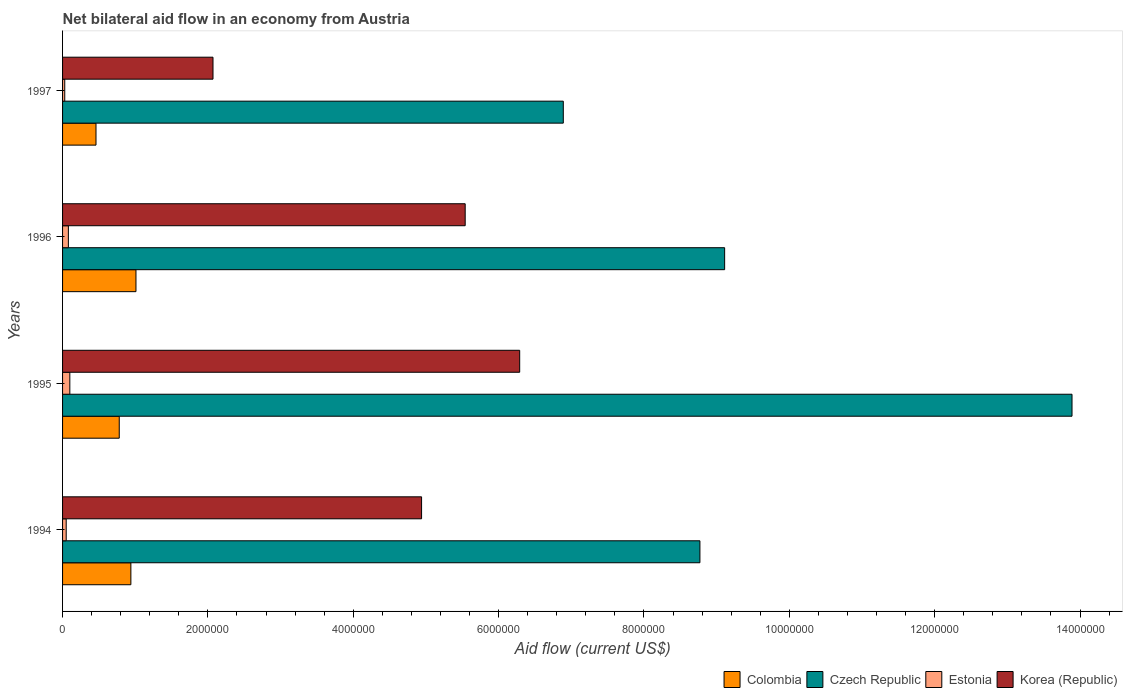How many different coloured bars are there?
Your answer should be compact. 4. Are the number of bars per tick equal to the number of legend labels?
Give a very brief answer. Yes. How many bars are there on the 2nd tick from the top?
Make the answer very short. 4. How many bars are there on the 2nd tick from the bottom?
Provide a succinct answer. 4. In how many cases, is the number of bars for a given year not equal to the number of legend labels?
Give a very brief answer. 0. What is the net bilateral aid flow in Czech Republic in 1994?
Provide a succinct answer. 8.77e+06. Across all years, what is the maximum net bilateral aid flow in Colombia?
Provide a succinct answer. 1.01e+06. Across all years, what is the minimum net bilateral aid flow in Colombia?
Give a very brief answer. 4.60e+05. What is the total net bilateral aid flow in Korea (Republic) in the graph?
Make the answer very short. 1.88e+07. What is the difference between the net bilateral aid flow in Colombia in 1995 and that in 1996?
Provide a short and direct response. -2.30e+05. What is the difference between the net bilateral aid flow in Estonia in 1995 and the net bilateral aid flow in Colombia in 1997?
Offer a very short reply. -3.60e+05. What is the average net bilateral aid flow in Colombia per year?
Your answer should be compact. 7.98e+05. In the year 1997, what is the difference between the net bilateral aid flow in Czech Republic and net bilateral aid flow in Korea (Republic)?
Provide a succinct answer. 4.82e+06. What is the ratio of the net bilateral aid flow in Korea (Republic) in 1995 to that in 1997?
Offer a terse response. 3.04. Is the difference between the net bilateral aid flow in Czech Republic in 1994 and 1996 greater than the difference between the net bilateral aid flow in Korea (Republic) in 1994 and 1996?
Make the answer very short. Yes. What is the difference between the highest and the lowest net bilateral aid flow in Estonia?
Ensure brevity in your answer.  7.00e+04. In how many years, is the net bilateral aid flow in Estonia greater than the average net bilateral aid flow in Estonia taken over all years?
Your answer should be very brief. 2. Is it the case that in every year, the sum of the net bilateral aid flow in Czech Republic and net bilateral aid flow in Colombia is greater than the sum of net bilateral aid flow in Korea (Republic) and net bilateral aid flow in Estonia?
Give a very brief answer. No. What does the 3rd bar from the top in 1995 represents?
Offer a terse response. Czech Republic. Is it the case that in every year, the sum of the net bilateral aid flow in Estonia and net bilateral aid flow in Czech Republic is greater than the net bilateral aid flow in Colombia?
Your answer should be very brief. Yes. How many bars are there?
Ensure brevity in your answer.  16. How many years are there in the graph?
Give a very brief answer. 4. What is the difference between two consecutive major ticks on the X-axis?
Provide a succinct answer. 2.00e+06. Are the values on the major ticks of X-axis written in scientific E-notation?
Your response must be concise. No. Does the graph contain any zero values?
Offer a terse response. No. Does the graph contain grids?
Keep it short and to the point. No. Where does the legend appear in the graph?
Offer a terse response. Bottom right. How many legend labels are there?
Ensure brevity in your answer.  4. What is the title of the graph?
Provide a succinct answer. Net bilateral aid flow in an economy from Austria. What is the label or title of the Y-axis?
Ensure brevity in your answer.  Years. What is the Aid flow (current US$) in Colombia in 1994?
Offer a very short reply. 9.40e+05. What is the Aid flow (current US$) of Czech Republic in 1994?
Make the answer very short. 8.77e+06. What is the Aid flow (current US$) of Estonia in 1994?
Provide a succinct answer. 5.00e+04. What is the Aid flow (current US$) in Korea (Republic) in 1994?
Provide a succinct answer. 4.94e+06. What is the Aid flow (current US$) in Colombia in 1995?
Your answer should be very brief. 7.80e+05. What is the Aid flow (current US$) in Czech Republic in 1995?
Offer a terse response. 1.39e+07. What is the Aid flow (current US$) in Estonia in 1995?
Give a very brief answer. 1.00e+05. What is the Aid flow (current US$) in Korea (Republic) in 1995?
Your answer should be compact. 6.29e+06. What is the Aid flow (current US$) in Colombia in 1996?
Give a very brief answer. 1.01e+06. What is the Aid flow (current US$) of Czech Republic in 1996?
Give a very brief answer. 9.11e+06. What is the Aid flow (current US$) in Korea (Republic) in 1996?
Your answer should be compact. 5.54e+06. What is the Aid flow (current US$) of Colombia in 1997?
Make the answer very short. 4.60e+05. What is the Aid flow (current US$) of Czech Republic in 1997?
Your answer should be compact. 6.89e+06. What is the Aid flow (current US$) in Estonia in 1997?
Make the answer very short. 3.00e+04. What is the Aid flow (current US$) in Korea (Republic) in 1997?
Keep it short and to the point. 2.07e+06. Across all years, what is the maximum Aid flow (current US$) of Colombia?
Keep it short and to the point. 1.01e+06. Across all years, what is the maximum Aid flow (current US$) of Czech Republic?
Offer a terse response. 1.39e+07. Across all years, what is the maximum Aid flow (current US$) of Korea (Republic)?
Offer a terse response. 6.29e+06. Across all years, what is the minimum Aid flow (current US$) of Czech Republic?
Provide a short and direct response. 6.89e+06. Across all years, what is the minimum Aid flow (current US$) of Korea (Republic)?
Your answer should be compact. 2.07e+06. What is the total Aid flow (current US$) of Colombia in the graph?
Ensure brevity in your answer.  3.19e+06. What is the total Aid flow (current US$) in Czech Republic in the graph?
Provide a short and direct response. 3.87e+07. What is the total Aid flow (current US$) in Korea (Republic) in the graph?
Provide a succinct answer. 1.88e+07. What is the difference between the Aid flow (current US$) of Czech Republic in 1994 and that in 1995?
Provide a succinct answer. -5.12e+06. What is the difference between the Aid flow (current US$) of Estonia in 1994 and that in 1995?
Give a very brief answer. -5.00e+04. What is the difference between the Aid flow (current US$) in Korea (Republic) in 1994 and that in 1995?
Your response must be concise. -1.35e+06. What is the difference between the Aid flow (current US$) in Colombia in 1994 and that in 1996?
Provide a short and direct response. -7.00e+04. What is the difference between the Aid flow (current US$) in Czech Republic in 1994 and that in 1996?
Ensure brevity in your answer.  -3.40e+05. What is the difference between the Aid flow (current US$) in Estonia in 1994 and that in 1996?
Ensure brevity in your answer.  -3.00e+04. What is the difference between the Aid flow (current US$) in Korea (Republic) in 1994 and that in 1996?
Give a very brief answer. -6.00e+05. What is the difference between the Aid flow (current US$) of Colombia in 1994 and that in 1997?
Your answer should be compact. 4.80e+05. What is the difference between the Aid flow (current US$) in Czech Republic in 1994 and that in 1997?
Your answer should be very brief. 1.88e+06. What is the difference between the Aid flow (current US$) in Estonia in 1994 and that in 1997?
Provide a short and direct response. 2.00e+04. What is the difference between the Aid flow (current US$) in Korea (Republic) in 1994 and that in 1997?
Offer a terse response. 2.87e+06. What is the difference between the Aid flow (current US$) of Czech Republic in 1995 and that in 1996?
Ensure brevity in your answer.  4.78e+06. What is the difference between the Aid flow (current US$) of Estonia in 1995 and that in 1996?
Offer a very short reply. 2.00e+04. What is the difference between the Aid flow (current US$) in Korea (Republic) in 1995 and that in 1996?
Provide a succinct answer. 7.50e+05. What is the difference between the Aid flow (current US$) in Colombia in 1995 and that in 1997?
Offer a terse response. 3.20e+05. What is the difference between the Aid flow (current US$) of Estonia in 1995 and that in 1997?
Offer a very short reply. 7.00e+04. What is the difference between the Aid flow (current US$) in Korea (Republic) in 1995 and that in 1997?
Ensure brevity in your answer.  4.22e+06. What is the difference between the Aid flow (current US$) of Colombia in 1996 and that in 1997?
Your response must be concise. 5.50e+05. What is the difference between the Aid flow (current US$) in Czech Republic in 1996 and that in 1997?
Provide a succinct answer. 2.22e+06. What is the difference between the Aid flow (current US$) of Korea (Republic) in 1996 and that in 1997?
Provide a short and direct response. 3.47e+06. What is the difference between the Aid flow (current US$) of Colombia in 1994 and the Aid flow (current US$) of Czech Republic in 1995?
Ensure brevity in your answer.  -1.30e+07. What is the difference between the Aid flow (current US$) in Colombia in 1994 and the Aid flow (current US$) in Estonia in 1995?
Give a very brief answer. 8.40e+05. What is the difference between the Aid flow (current US$) of Colombia in 1994 and the Aid flow (current US$) of Korea (Republic) in 1995?
Ensure brevity in your answer.  -5.35e+06. What is the difference between the Aid flow (current US$) of Czech Republic in 1994 and the Aid flow (current US$) of Estonia in 1995?
Offer a very short reply. 8.67e+06. What is the difference between the Aid flow (current US$) in Czech Republic in 1994 and the Aid flow (current US$) in Korea (Republic) in 1995?
Provide a short and direct response. 2.48e+06. What is the difference between the Aid flow (current US$) in Estonia in 1994 and the Aid flow (current US$) in Korea (Republic) in 1995?
Offer a terse response. -6.24e+06. What is the difference between the Aid flow (current US$) of Colombia in 1994 and the Aid flow (current US$) of Czech Republic in 1996?
Ensure brevity in your answer.  -8.17e+06. What is the difference between the Aid flow (current US$) in Colombia in 1994 and the Aid flow (current US$) in Estonia in 1996?
Give a very brief answer. 8.60e+05. What is the difference between the Aid flow (current US$) of Colombia in 1994 and the Aid flow (current US$) of Korea (Republic) in 1996?
Give a very brief answer. -4.60e+06. What is the difference between the Aid flow (current US$) of Czech Republic in 1994 and the Aid flow (current US$) of Estonia in 1996?
Provide a short and direct response. 8.69e+06. What is the difference between the Aid flow (current US$) in Czech Republic in 1994 and the Aid flow (current US$) in Korea (Republic) in 1996?
Offer a terse response. 3.23e+06. What is the difference between the Aid flow (current US$) in Estonia in 1994 and the Aid flow (current US$) in Korea (Republic) in 1996?
Offer a terse response. -5.49e+06. What is the difference between the Aid flow (current US$) of Colombia in 1994 and the Aid flow (current US$) of Czech Republic in 1997?
Make the answer very short. -5.95e+06. What is the difference between the Aid flow (current US$) in Colombia in 1994 and the Aid flow (current US$) in Estonia in 1997?
Your answer should be very brief. 9.10e+05. What is the difference between the Aid flow (current US$) of Colombia in 1994 and the Aid flow (current US$) of Korea (Republic) in 1997?
Offer a very short reply. -1.13e+06. What is the difference between the Aid flow (current US$) of Czech Republic in 1994 and the Aid flow (current US$) of Estonia in 1997?
Provide a succinct answer. 8.74e+06. What is the difference between the Aid flow (current US$) of Czech Republic in 1994 and the Aid flow (current US$) of Korea (Republic) in 1997?
Keep it short and to the point. 6.70e+06. What is the difference between the Aid flow (current US$) of Estonia in 1994 and the Aid flow (current US$) of Korea (Republic) in 1997?
Ensure brevity in your answer.  -2.02e+06. What is the difference between the Aid flow (current US$) in Colombia in 1995 and the Aid flow (current US$) in Czech Republic in 1996?
Your answer should be very brief. -8.33e+06. What is the difference between the Aid flow (current US$) in Colombia in 1995 and the Aid flow (current US$) in Estonia in 1996?
Offer a terse response. 7.00e+05. What is the difference between the Aid flow (current US$) of Colombia in 1995 and the Aid flow (current US$) of Korea (Republic) in 1996?
Ensure brevity in your answer.  -4.76e+06. What is the difference between the Aid flow (current US$) in Czech Republic in 1995 and the Aid flow (current US$) in Estonia in 1996?
Your answer should be compact. 1.38e+07. What is the difference between the Aid flow (current US$) in Czech Republic in 1995 and the Aid flow (current US$) in Korea (Republic) in 1996?
Your response must be concise. 8.35e+06. What is the difference between the Aid flow (current US$) in Estonia in 1995 and the Aid flow (current US$) in Korea (Republic) in 1996?
Provide a succinct answer. -5.44e+06. What is the difference between the Aid flow (current US$) of Colombia in 1995 and the Aid flow (current US$) of Czech Republic in 1997?
Offer a terse response. -6.11e+06. What is the difference between the Aid flow (current US$) in Colombia in 1995 and the Aid flow (current US$) in Estonia in 1997?
Your answer should be very brief. 7.50e+05. What is the difference between the Aid flow (current US$) in Colombia in 1995 and the Aid flow (current US$) in Korea (Republic) in 1997?
Provide a short and direct response. -1.29e+06. What is the difference between the Aid flow (current US$) in Czech Republic in 1995 and the Aid flow (current US$) in Estonia in 1997?
Provide a short and direct response. 1.39e+07. What is the difference between the Aid flow (current US$) of Czech Republic in 1995 and the Aid flow (current US$) of Korea (Republic) in 1997?
Ensure brevity in your answer.  1.18e+07. What is the difference between the Aid flow (current US$) of Estonia in 1995 and the Aid flow (current US$) of Korea (Republic) in 1997?
Provide a short and direct response. -1.97e+06. What is the difference between the Aid flow (current US$) in Colombia in 1996 and the Aid flow (current US$) in Czech Republic in 1997?
Provide a short and direct response. -5.88e+06. What is the difference between the Aid flow (current US$) of Colombia in 1996 and the Aid flow (current US$) of Estonia in 1997?
Provide a short and direct response. 9.80e+05. What is the difference between the Aid flow (current US$) in Colombia in 1996 and the Aid flow (current US$) in Korea (Republic) in 1997?
Your answer should be compact. -1.06e+06. What is the difference between the Aid flow (current US$) in Czech Republic in 1996 and the Aid flow (current US$) in Estonia in 1997?
Ensure brevity in your answer.  9.08e+06. What is the difference between the Aid flow (current US$) of Czech Republic in 1996 and the Aid flow (current US$) of Korea (Republic) in 1997?
Provide a short and direct response. 7.04e+06. What is the difference between the Aid flow (current US$) in Estonia in 1996 and the Aid flow (current US$) in Korea (Republic) in 1997?
Your response must be concise. -1.99e+06. What is the average Aid flow (current US$) of Colombia per year?
Keep it short and to the point. 7.98e+05. What is the average Aid flow (current US$) in Czech Republic per year?
Give a very brief answer. 9.66e+06. What is the average Aid flow (current US$) of Estonia per year?
Give a very brief answer. 6.50e+04. What is the average Aid flow (current US$) of Korea (Republic) per year?
Your answer should be compact. 4.71e+06. In the year 1994, what is the difference between the Aid flow (current US$) in Colombia and Aid flow (current US$) in Czech Republic?
Make the answer very short. -7.83e+06. In the year 1994, what is the difference between the Aid flow (current US$) in Colombia and Aid flow (current US$) in Estonia?
Your response must be concise. 8.90e+05. In the year 1994, what is the difference between the Aid flow (current US$) in Colombia and Aid flow (current US$) in Korea (Republic)?
Provide a succinct answer. -4.00e+06. In the year 1994, what is the difference between the Aid flow (current US$) in Czech Republic and Aid flow (current US$) in Estonia?
Offer a terse response. 8.72e+06. In the year 1994, what is the difference between the Aid flow (current US$) in Czech Republic and Aid flow (current US$) in Korea (Republic)?
Provide a short and direct response. 3.83e+06. In the year 1994, what is the difference between the Aid flow (current US$) of Estonia and Aid flow (current US$) of Korea (Republic)?
Your answer should be very brief. -4.89e+06. In the year 1995, what is the difference between the Aid flow (current US$) of Colombia and Aid flow (current US$) of Czech Republic?
Your response must be concise. -1.31e+07. In the year 1995, what is the difference between the Aid flow (current US$) of Colombia and Aid flow (current US$) of Estonia?
Make the answer very short. 6.80e+05. In the year 1995, what is the difference between the Aid flow (current US$) in Colombia and Aid flow (current US$) in Korea (Republic)?
Your answer should be compact. -5.51e+06. In the year 1995, what is the difference between the Aid flow (current US$) of Czech Republic and Aid flow (current US$) of Estonia?
Make the answer very short. 1.38e+07. In the year 1995, what is the difference between the Aid flow (current US$) of Czech Republic and Aid flow (current US$) of Korea (Republic)?
Your response must be concise. 7.60e+06. In the year 1995, what is the difference between the Aid flow (current US$) in Estonia and Aid flow (current US$) in Korea (Republic)?
Your response must be concise. -6.19e+06. In the year 1996, what is the difference between the Aid flow (current US$) of Colombia and Aid flow (current US$) of Czech Republic?
Provide a succinct answer. -8.10e+06. In the year 1996, what is the difference between the Aid flow (current US$) of Colombia and Aid flow (current US$) of Estonia?
Offer a terse response. 9.30e+05. In the year 1996, what is the difference between the Aid flow (current US$) of Colombia and Aid flow (current US$) of Korea (Republic)?
Provide a short and direct response. -4.53e+06. In the year 1996, what is the difference between the Aid flow (current US$) in Czech Republic and Aid flow (current US$) in Estonia?
Make the answer very short. 9.03e+06. In the year 1996, what is the difference between the Aid flow (current US$) in Czech Republic and Aid flow (current US$) in Korea (Republic)?
Make the answer very short. 3.57e+06. In the year 1996, what is the difference between the Aid flow (current US$) in Estonia and Aid flow (current US$) in Korea (Republic)?
Keep it short and to the point. -5.46e+06. In the year 1997, what is the difference between the Aid flow (current US$) of Colombia and Aid flow (current US$) of Czech Republic?
Provide a short and direct response. -6.43e+06. In the year 1997, what is the difference between the Aid flow (current US$) of Colombia and Aid flow (current US$) of Korea (Republic)?
Provide a short and direct response. -1.61e+06. In the year 1997, what is the difference between the Aid flow (current US$) of Czech Republic and Aid flow (current US$) of Estonia?
Give a very brief answer. 6.86e+06. In the year 1997, what is the difference between the Aid flow (current US$) in Czech Republic and Aid flow (current US$) in Korea (Republic)?
Your answer should be compact. 4.82e+06. In the year 1997, what is the difference between the Aid flow (current US$) of Estonia and Aid flow (current US$) of Korea (Republic)?
Provide a short and direct response. -2.04e+06. What is the ratio of the Aid flow (current US$) in Colombia in 1994 to that in 1995?
Your answer should be compact. 1.21. What is the ratio of the Aid flow (current US$) in Czech Republic in 1994 to that in 1995?
Provide a short and direct response. 0.63. What is the ratio of the Aid flow (current US$) in Estonia in 1994 to that in 1995?
Your answer should be compact. 0.5. What is the ratio of the Aid flow (current US$) of Korea (Republic) in 1994 to that in 1995?
Your answer should be compact. 0.79. What is the ratio of the Aid flow (current US$) of Colombia in 1994 to that in 1996?
Keep it short and to the point. 0.93. What is the ratio of the Aid flow (current US$) in Czech Republic in 1994 to that in 1996?
Your response must be concise. 0.96. What is the ratio of the Aid flow (current US$) of Estonia in 1994 to that in 1996?
Your answer should be very brief. 0.62. What is the ratio of the Aid flow (current US$) of Korea (Republic) in 1994 to that in 1996?
Offer a terse response. 0.89. What is the ratio of the Aid flow (current US$) of Colombia in 1994 to that in 1997?
Keep it short and to the point. 2.04. What is the ratio of the Aid flow (current US$) of Czech Republic in 1994 to that in 1997?
Give a very brief answer. 1.27. What is the ratio of the Aid flow (current US$) of Korea (Republic) in 1994 to that in 1997?
Keep it short and to the point. 2.39. What is the ratio of the Aid flow (current US$) in Colombia in 1995 to that in 1996?
Provide a short and direct response. 0.77. What is the ratio of the Aid flow (current US$) of Czech Republic in 1995 to that in 1996?
Your answer should be compact. 1.52. What is the ratio of the Aid flow (current US$) of Estonia in 1995 to that in 1996?
Your response must be concise. 1.25. What is the ratio of the Aid flow (current US$) of Korea (Republic) in 1995 to that in 1996?
Offer a very short reply. 1.14. What is the ratio of the Aid flow (current US$) of Colombia in 1995 to that in 1997?
Provide a succinct answer. 1.7. What is the ratio of the Aid flow (current US$) in Czech Republic in 1995 to that in 1997?
Your answer should be compact. 2.02. What is the ratio of the Aid flow (current US$) in Korea (Republic) in 1995 to that in 1997?
Offer a very short reply. 3.04. What is the ratio of the Aid flow (current US$) of Colombia in 1996 to that in 1997?
Keep it short and to the point. 2.2. What is the ratio of the Aid flow (current US$) of Czech Republic in 1996 to that in 1997?
Provide a succinct answer. 1.32. What is the ratio of the Aid flow (current US$) of Estonia in 1996 to that in 1997?
Provide a short and direct response. 2.67. What is the ratio of the Aid flow (current US$) of Korea (Republic) in 1996 to that in 1997?
Keep it short and to the point. 2.68. What is the difference between the highest and the second highest Aid flow (current US$) of Czech Republic?
Give a very brief answer. 4.78e+06. What is the difference between the highest and the second highest Aid flow (current US$) of Korea (Republic)?
Your answer should be very brief. 7.50e+05. What is the difference between the highest and the lowest Aid flow (current US$) of Czech Republic?
Your response must be concise. 7.00e+06. What is the difference between the highest and the lowest Aid flow (current US$) in Estonia?
Your response must be concise. 7.00e+04. What is the difference between the highest and the lowest Aid flow (current US$) of Korea (Republic)?
Your answer should be compact. 4.22e+06. 